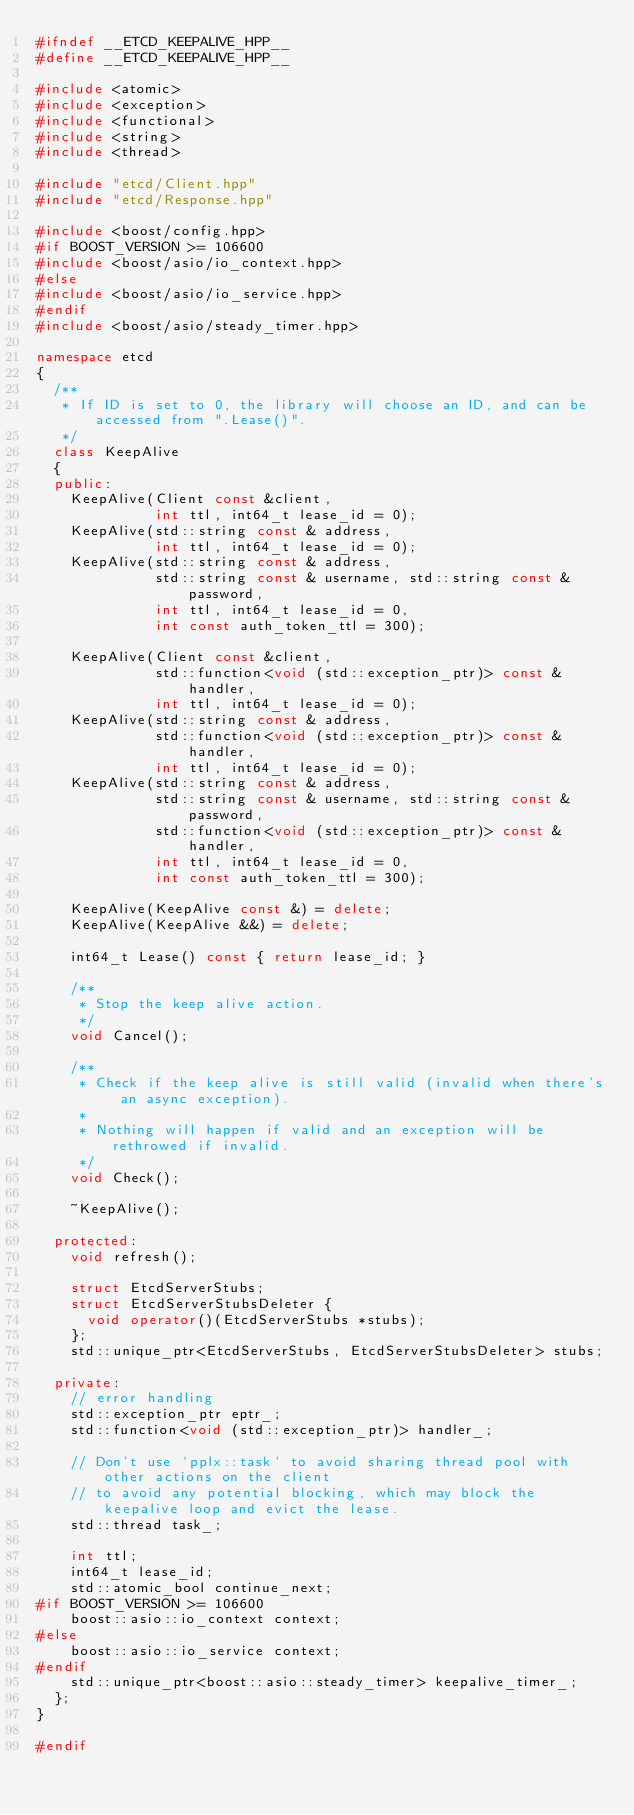Convert code to text. <code><loc_0><loc_0><loc_500><loc_500><_C++_>#ifndef __ETCD_KEEPALIVE_HPP__
#define __ETCD_KEEPALIVE_HPP__

#include <atomic>
#include <exception>
#include <functional>
#include <string>
#include <thread>

#include "etcd/Client.hpp"
#include "etcd/Response.hpp"

#include <boost/config.hpp>
#if BOOST_VERSION >= 106600
#include <boost/asio/io_context.hpp>
#else
#include <boost/asio/io_service.hpp>
#endif
#include <boost/asio/steady_timer.hpp>

namespace etcd
{
  /**
   * If ID is set to 0, the library will choose an ID, and can be accessed from ".Lease()".
   */
  class KeepAlive
  {
  public:
    KeepAlive(Client const &client,
              int ttl, int64_t lease_id = 0);
    KeepAlive(std::string const & address,
              int ttl, int64_t lease_id = 0);
    KeepAlive(std::string const & address,
              std::string const & username, std::string const & password,
              int ttl, int64_t lease_id = 0,
              int const auth_token_ttl = 300);

    KeepAlive(Client const &client,
              std::function<void (std::exception_ptr)> const &handler,
              int ttl, int64_t lease_id = 0);
    KeepAlive(std::string const & address,
              std::function<void (std::exception_ptr)> const &handler,
              int ttl, int64_t lease_id = 0);
    KeepAlive(std::string const & address,
              std::string const & username, std::string const & password,
              std::function<void (std::exception_ptr)> const &handler,
              int ttl, int64_t lease_id = 0,
              int const auth_token_ttl = 300);

    KeepAlive(KeepAlive const &) = delete;
    KeepAlive(KeepAlive &&) = delete;

    int64_t Lease() const { return lease_id; }

    /**
     * Stop the keep alive action.
     */
    void Cancel();

    /**
     * Check if the keep alive is still valid (invalid when there's an async exception).
     *
     * Nothing will happen if valid and an exception will be rethrowed if invalid.
     */
    void Check();

    ~KeepAlive();

  protected:
    void refresh();

    struct EtcdServerStubs;
    struct EtcdServerStubsDeleter {
      void operator()(EtcdServerStubs *stubs);
    };
    std::unique_ptr<EtcdServerStubs, EtcdServerStubsDeleter> stubs;

  private:
    // error handling
    std::exception_ptr eptr_;
    std::function<void (std::exception_ptr)> handler_;

    // Don't use `pplx::task` to avoid sharing thread pool with other actions on the client
    // to avoid any potential blocking, which may block the keepalive loop and evict the lease.
    std::thread task_;

    int ttl;
    int64_t lease_id;
    std::atomic_bool continue_next;
#if BOOST_VERSION >= 106600
    boost::asio::io_context context;
#else
    boost::asio::io_service context;
#endif
    std::unique_ptr<boost::asio::steady_timer> keepalive_timer_;
  };
}

#endif
</code> 